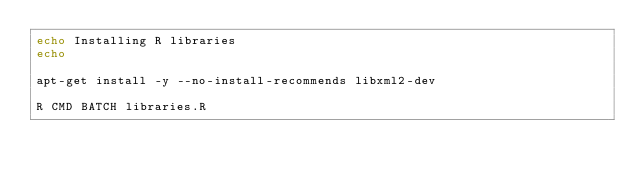<code> <loc_0><loc_0><loc_500><loc_500><_Bash_>echo Installing R libraries
echo

apt-get install -y --no-install-recommends libxml2-dev

R CMD BATCH libraries.R
</code> 